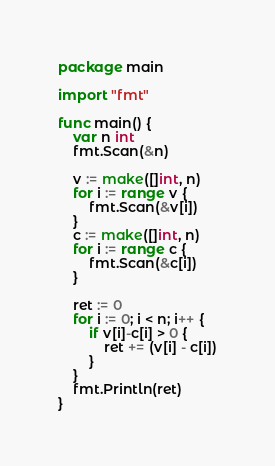Convert code to text. <code><loc_0><loc_0><loc_500><loc_500><_Go_>package main

import "fmt"

func main() {
	var n int
	fmt.Scan(&n)

	v := make([]int, n)
	for i := range v {
		fmt.Scan(&v[i])
	}
	c := make([]int, n)
	for i := range c {
		fmt.Scan(&c[i])
	}

	ret := 0
	for i := 0; i < n; i++ {
		if v[i]-c[i] > 0 {
			ret += (v[i] - c[i])
		}
	}
	fmt.Println(ret)
}
</code> 